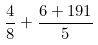<formula> <loc_0><loc_0><loc_500><loc_500>\frac { 4 } { 8 } + \frac { 6 + 1 9 1 } { 5 }</formula> 